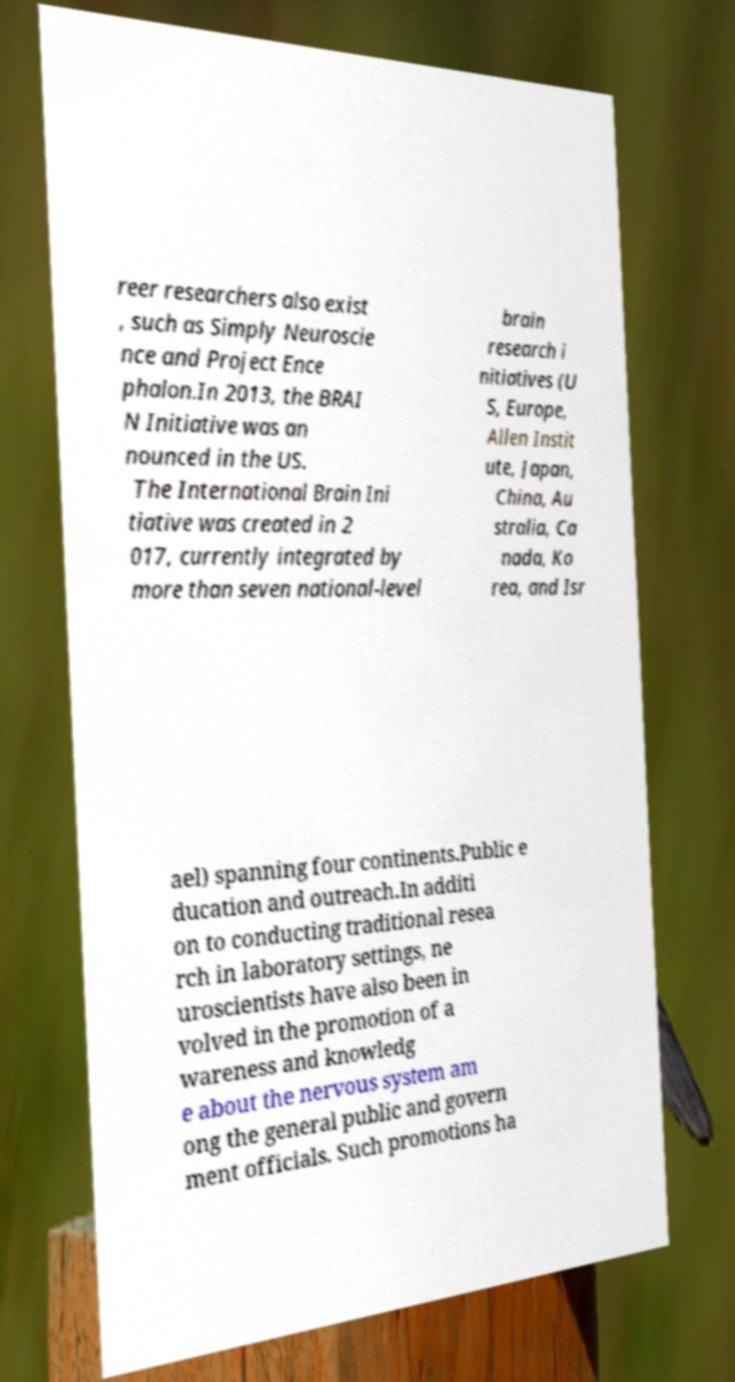Can you accurately transcribe the text from the provided image for me? reer researchers also exist , such as Simply Neuroscie nce and Project Ence phalon.In 2013, the BRAI N Initiative was an nounced in the US. The International Brain Ini tiative was created in 2 017, currently integrated by more than seven national-level brain research i nitiatives (U S, Europe, Allen Instit ute, Japan, China, Au stralia, Ca nada, Ko rea, and Isr ael) spanning four continents.Public e ducation and outreach.In additi on to conducting traditional resea rch in laboratory settings, ne uroscientists have also been in volved in the promotion of a wareness and knowledg e about the nervous system am ong the general public and govern ment officials. Such promotions ha 